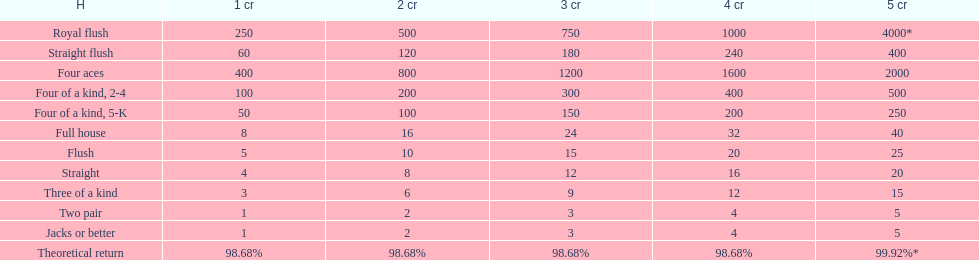Would you mind parsing the complete table? {'header': ['H', '1 cr', '2 cr', '3 cr', '4 cr', '5 cr'], 'rows': [['Royal flush', '250', '500', '750', '1000', '4000*'], ['Straight flush', '60', '120', '180', '240', '400'], ['Four aces', '400', '800', '1200', '1600', '2000'], ['Four of a kind, 2-4', '100', '200', '300', '400', '500'], ['Four of a kind, 5-K', '50', '100', '150', '200', '250'], ['Full house', '8', '16', '24', '32', '40'], ['Flush', '5', '10', '15', '20', '25'], ['Straight', '4', '8', '12', '16', '20'], ['Three of a kind', '3', '6', '9', '12', '15'], ['Two pair', '1', '2', '3', '4', '5'], ['Jacks or better', '1', '2', '3', '4', '5'], ['Theoretical return', '98.68%', '98.68%', '98.68%', '98.68%', '99.92%*']]} At most, what could a person earn for having a full house? 40. 